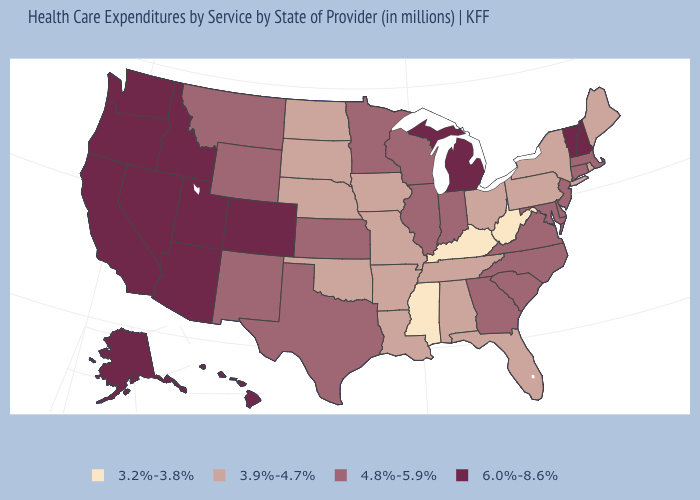Does the first symbol in the legend represent the smallest category?
Quick response, please. Yes. What is the value of Maryland?
Be succinct. 4.8%-5.9%. What is the lowest value in the USA?
Keep it brief. 3.2%-3.8%. Name the states that have a value in the range 3.2%-3.8%?
Write a very short answer. Kentucky, Mississippi, West Virginia. What is the value of West Virginia?
Concise answer only. 3.2%-3.8%. Name the states that have a value in the range 4.8%-5.9%?
Be succinct. Connecticut, Delaware, Georgia, Illinois, Indiana, Kansas, Maryland, Massachusetts, Minnesota, Montana, New Jersey, New Mexico, North Carolina, South Carolina, Texas, Virginia, Wisconsin, Wyoming. Which states have the lowest value in the Northeast?
Short answer required. Maine, New York, Pennsylvania, Rhode Island. Name the states that have a value in the range 4.8%-5.9%?
Give a very brief answer. Connecticut, Delaware, Georgia, Illinois, Indiana, Kansas, Maryland, Massachusetts, Minnesota, Montana, New Jersey, New Mexico, North Carolina, South Carolina, Texas, Virginia, Wisconsin, Wyoming. Name the states that have a value in the range 3.9%-4.7%?
Short answer required. Alabama, Arkansas, Florida, Iowa, Louisiana, Maine, Missouri, Nebraska, New York, North Dakota, Ohio, Oklahoma, Pennsylvania, Rhode Island, South Dakota, Tennessee. What is the highest value in the USA?
Keep it brief. 6.0%-8.6%. Name the states that have a value in the range 3.9%-4.7%?
Quick response, please. Alabama, Arkansas, Florida, Iowa, Louisiana, Maine, Missouri, Nebraska, New York, North Dakota, Ohio, Oklahoma, Pennsylvania, Rhode Island, South Dakota, Tennessee. Does Michigan have the lowest value in the MidWest?
Give a very brief answer. No. What is the lowest value in the South?
Short answer required. 3.2%-3.8%. Which states have the lowest value in the USA?
Quick response, please. Kentucky, Mississippi, West Virginia. Does Arkansas have the lowest value in the USA?
Quick response, please. No. 